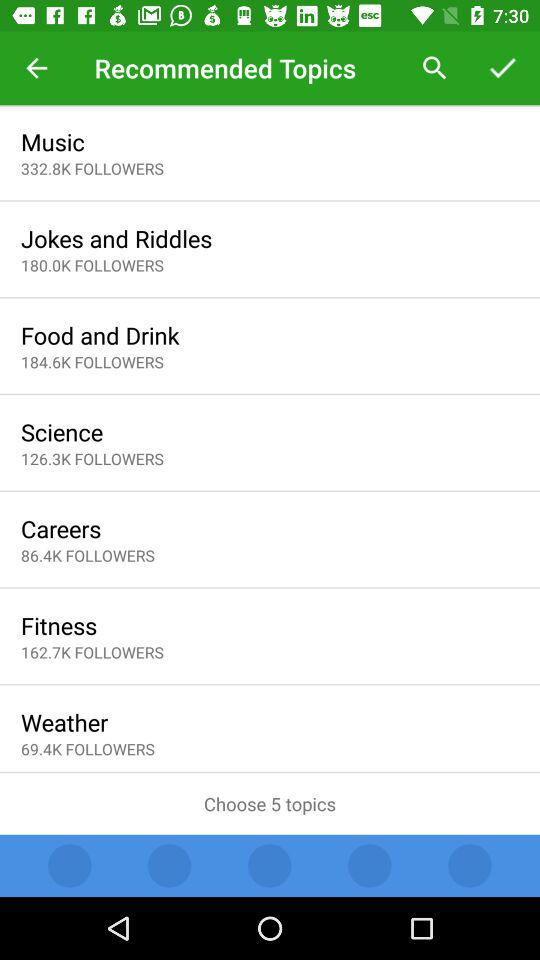How many followers are there for "Food and Drink"? There are 184.6K followers. 